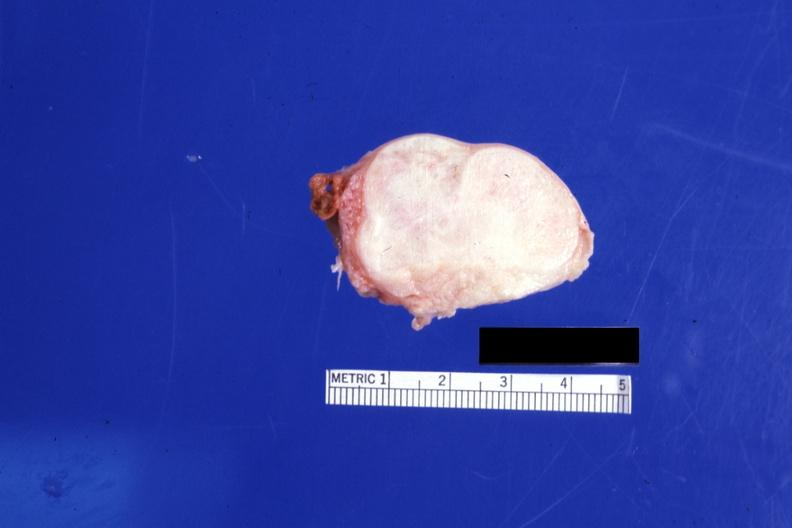s sella present?
Answer the question using a single word or phrase. No 